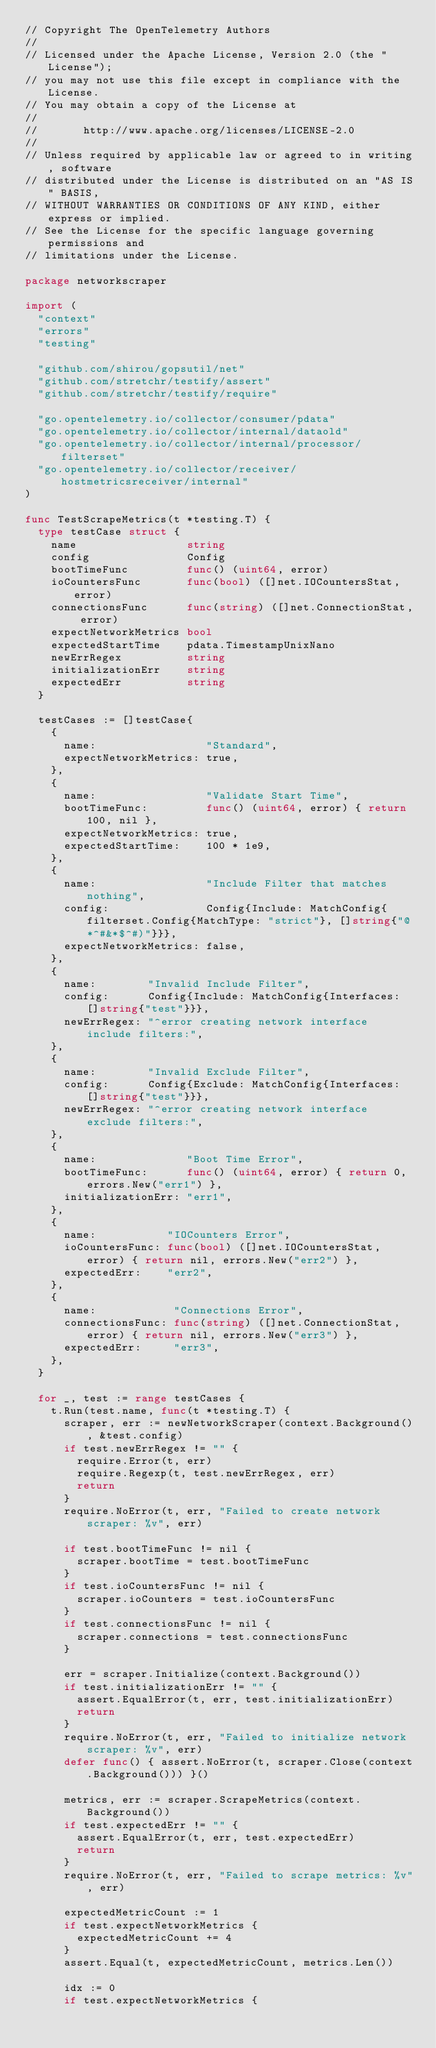Convert code to text. <code><loc_0><loc_0><loc_500><loc_500><_Go_>// Copyright The OpenTelemetry Authors
//
// Licensed under the Apache License, Version 2.0 (the "License");
// you may not use this file except in compliance with the License.
// You may obtain a copy of the License at
//
//       http://www.apache.org/licenses/LICENSE-2.0
//
// Unless required by applicable law or agreed to in writing, software
// distributed under the License is distributed on an "AS IS" BASIS,
// WITHOUT WARRANTIES OR CONDITIONS OF ANY KIND, either express or implied.
// See the License for the specific language governing permissions and
// limitations under the License.

package networkscraper

import (
	"context"
	"errors"
	"testing"

	"github.com/shirou/gopsutil/net"
	"github.com/stretchr/testify/assert"
	"github.com/stretchr/testify/require"

	"go.opentelemetry.io/collector/consumer/pdata"
	"go.opentelemetry.io/collector/internal/dataold"
	"go.opentelemetry.io/collector/internal/processor/filterset"
	"go.opentelemetry.io/collector/receiver/hostmetricsreceiver/internal"
)

func TestScrapeMetrics(t *testing.T) {
	type testCase struct {
		name                 string
		config               Config
		bootTimeFunc         func() (uint64, error)
		ioCountersFunc       func(bool) ([]net.IOCountersStat, error)
		connectionsFunc      func(string) ([]net.ConnectionStat, error)
		expectNetworkMetrics bool
		expectedStartTime    pdata.TimestampUnixNano
		newErrRegex          string
		initializationErr    string
		expectedErr          string
	}

	testCases := []testCase{
		{
			name:                 "Standard",
			expectNetworkMetrics: true,
		},
		{
			name:                 "Validate Start Time",
			bootTimeFunc:         func() (uint64, error) { return 100, nil },
			expectNetworkMetrics: true,
			expectedStartTime:    100 * 1e9,
		},
		{
			name:                 "Include Filter that matches nothing",
			config:               Config{Include: MatchConfig{filterset.Config{MatchType: "strict"}, []string{"@*^#&*$^#)"}}},
			expectNetworkMetrics: false,
		},
		{
			name:        "Invalid Include Filter",
			config:      Config{Include: MatchConfig{Interfaces: []string{"test"}}},
			newErrRegex: "^error creating network interface include filters:",
		},
		{
			name:        "Invalid Exclude Filter",
			config:      Config{Exclude: MatchConfig{Interfaces: []string{"test"}}},
			newErrRegex: "^error creating network interface exclude filters:",
		},
		{
			name:              "Boot Time Error",
			bootTimeFunc:      func() (uint64, error) { return 0, errors.New("err1") },
			initializationErr: "err1",
		},
		{
			name:           "IOCounters Error",
			ioCountersFunc: func(bool) ([]net.IOCountersStat, error) { return nil, errors.New("err2") },
			expectedErr:    "err2",
		},
		{
			name:            "Connections Error",
			connectionsFunc: func(string) ([]net.ConnectionStat, error) { return nil, errors.New("err3") },
			expectedErr:     "err3",
		},
	}

	for _, test := range testCases {
		t.Run(test.name, func(t *testing.T) {
			scraper, err := newNetworkScraper(context.Background(), &test.config)
			if test.newErrRegex != "" {
				require.Error(t, err)
				require.Regexp(t, test.newErrRegex, err)
				return
			}
			require.NoError(t, err, "Failed to create network scraper: %v", err)

			if test.bootTimeFunc != nil {
				scraper.bootTime = test.bootTimeFunc
			}
			if test.ioCountersFunc != nil {
				scraper.ioCounters = test.ioCountersFunc
			}
			if test.connectionsFunc != nil {
				scraper.connections = test.connectionsFunc
			}

			err = scraper.Initialize(context.Background())
			if test.initializationErr != "" {
				assert.EqualError(t, err, test.initializationErr)
				return
			}
			require.NoError(t, err, "Failed to initialize network scraper: %v", err)
			defer func() { assert.NoError(t, scraper.Close(context.Background())) }()

			metrics, err := scraper.ScrapeMetrics(context.Background())
			if test.expectedErr != "" {
				assert.EqualError(t, err, test.expectedErr)
				return
			}
			require.NoError(t, err, "Failed to scrape metrics: %v", err)

			expectedMetricCount := 1
			if test.expectNetworkMetrics {
				expectedMetricCount += 4
			}
			assert.Equal(t, expectedMetricCount, metrics.Len())

			idx := 0
			if test.expectNetworkMetrics {</code> 